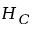<formula> <loc_0><loc_0><loc_500><loc_500>H _ { C }</formula> 